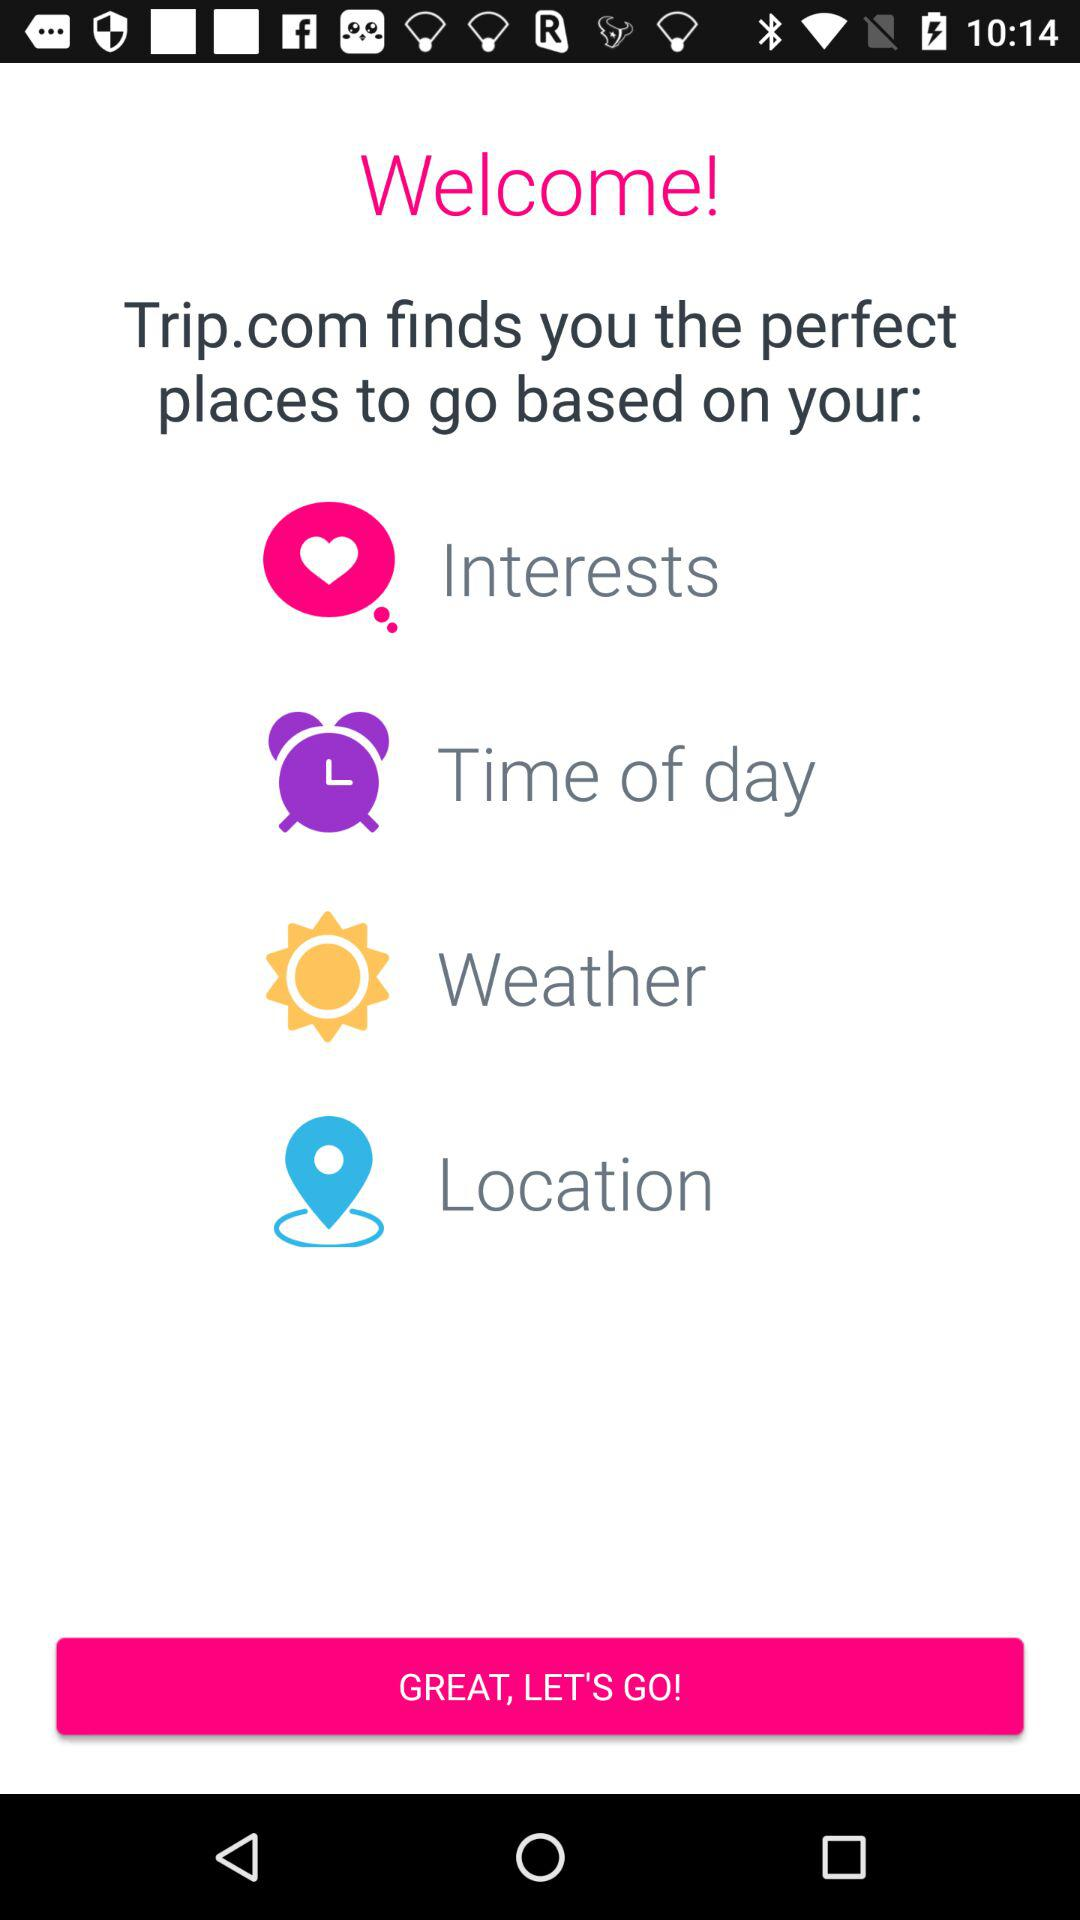What is the application name? The application name is "Trip.com". 